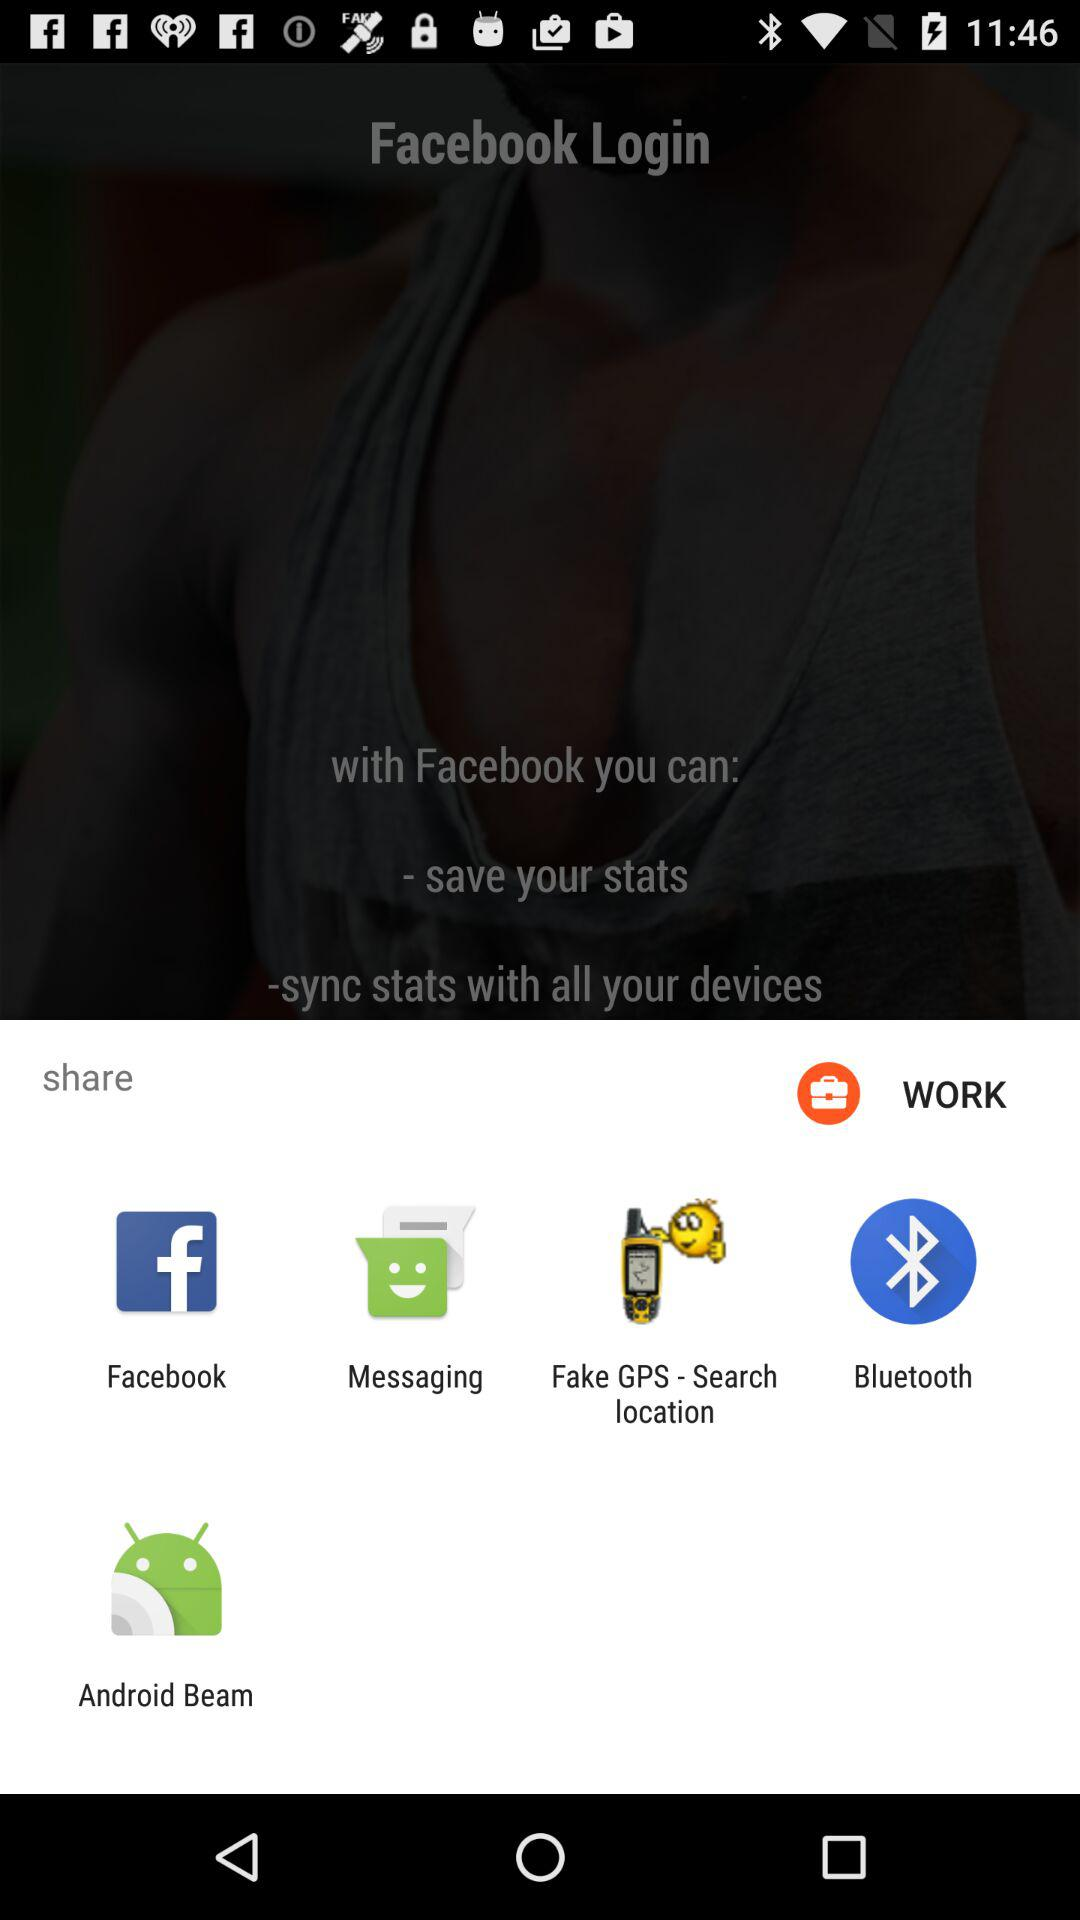What's the content type that is to be shared? The content type that is to be shared is "WORK". 